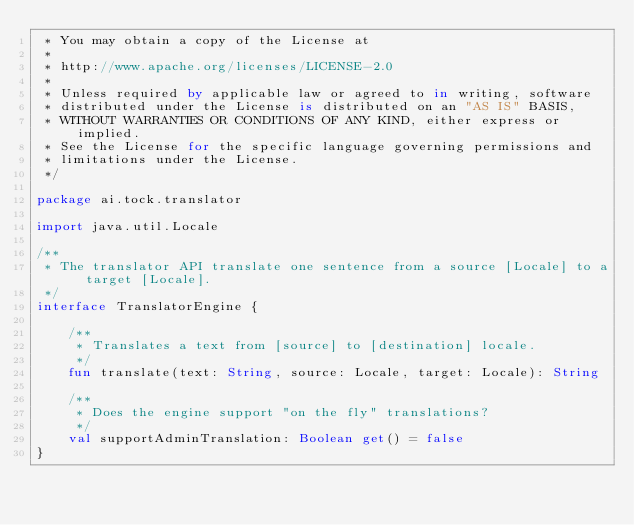<code> <loc_0><loc_0><loc_500><loc_500><_Kotlin_> * You may obtain a copy of the License at
 *
 * http://www.apache.org/licenses/LICENSE-2.0
 *
 * Unless required by applicable law or agreed to in writing, software
 * distributed under the License is distributed on an "AS IS" BASIS,
 * WITHOUT WARRANTIES OR CONDITIONS OF ANY KIND, either express or implied.
 * See the License for the specific language governing permissions and
 * limitations under the License.
 */

package ai.tock.translator

import java.util.Locale

/**
 * The translator API translate one sentence from a source [Locale] to a target [Locale].
 */
interface TranslatorEngine {

    /**
     * Translates a text from [source] to [destination] locale.
     */
    fun translate(text: String, source: Locale, target: Locale): String

    /**
     * Does the engine support "on the fly" translations?
     */
    val supportAdminTranslation: Boolean get() = false
}
</code> 